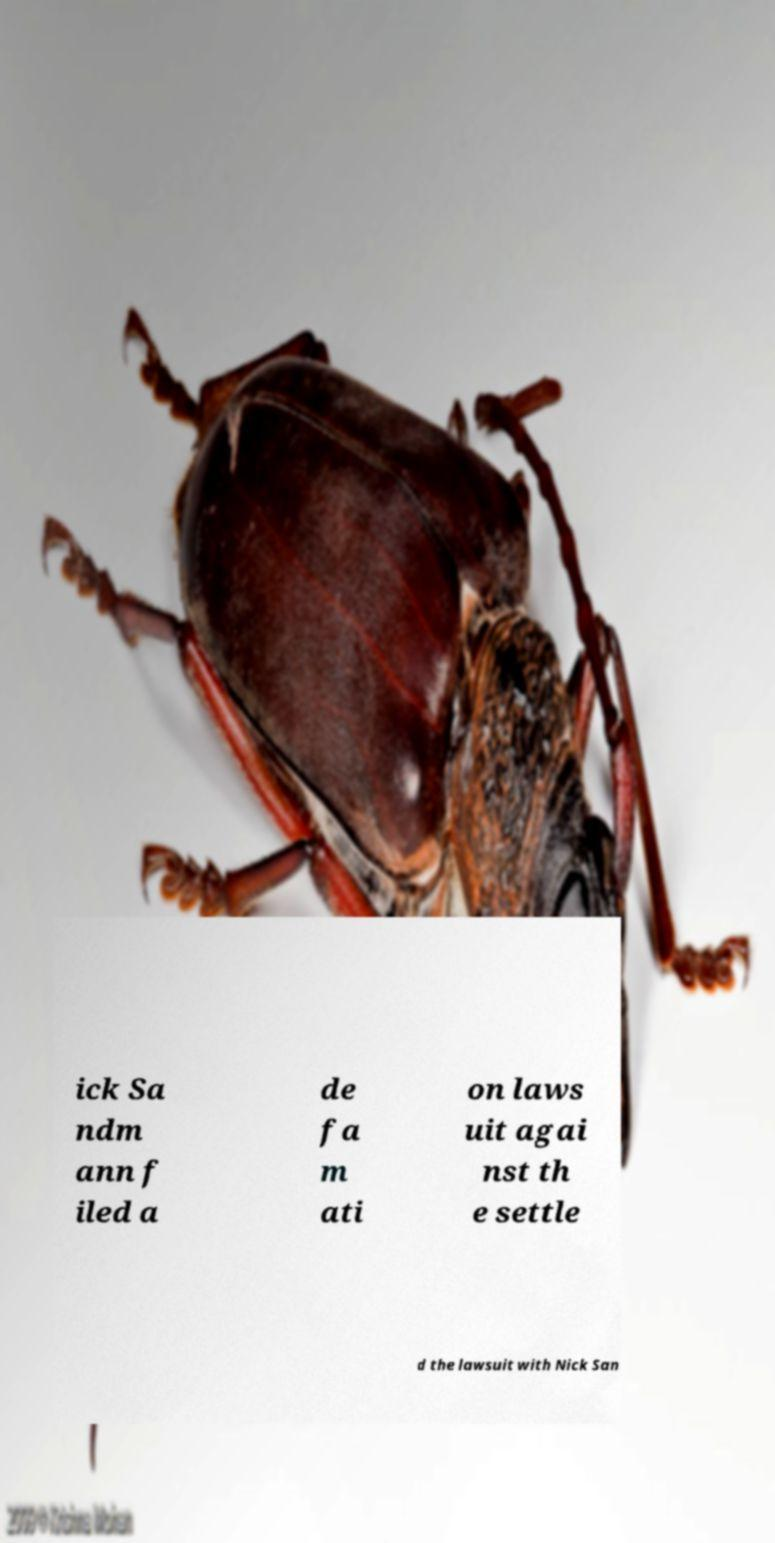There's text embedded in this image that I need extracted. Can you transcribe it verbatim? ick Sa ndm ann f iled a de fa m ati on laws uit agai nst th e settle d the lawsuit with Nick San 